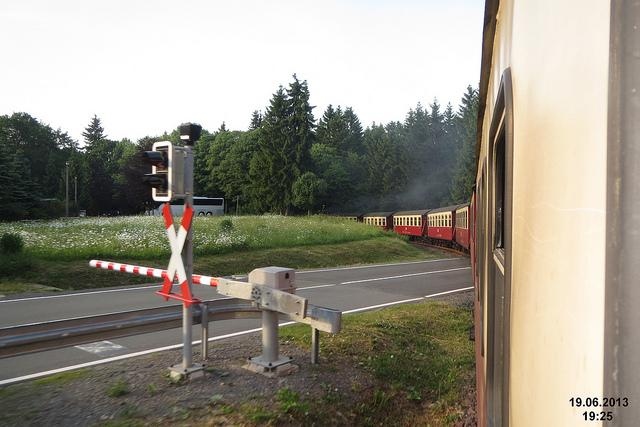What color is the area of the train car around the window? Please explain your reasoning. cream. The color is cream. 